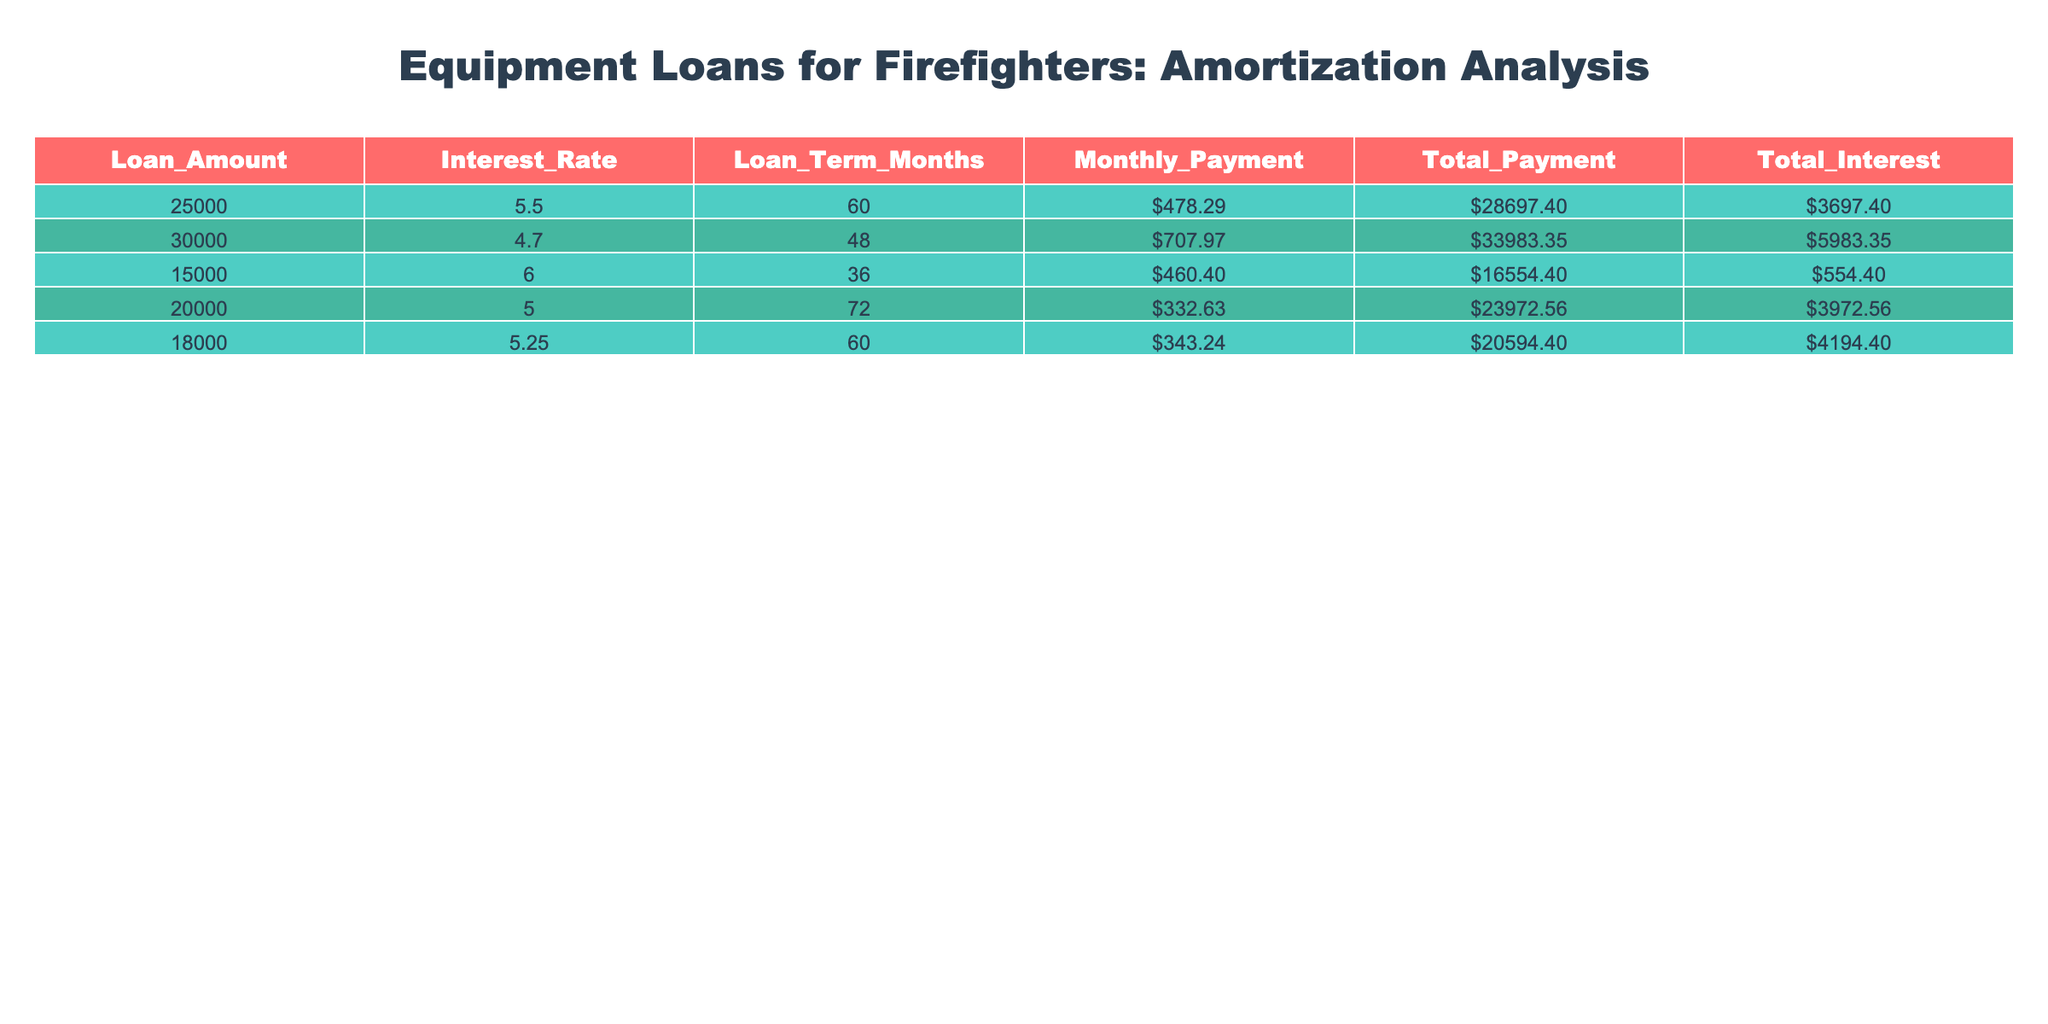What is the loan amount for the equipment with the lowest total interest? From the table, we check the Total Interest column to find the minimum value, which is 554.40. This corresponds to the loan amount of 15000.
Answer: 15000 What is the total payment for the loan with the highest monthly payment? Looking at the Monthly Payment column, the highest value is 707.97. We refer to the same row for the Total Payment, which is 33983.35.
Answer: 33983.35 What is the average total interest across all loans? We sum up all the total interest values: (3697.40 + 5983.35 + 554.40 + 3972.56 + 4194.40) = 18702.11. There are 5 loans, so we divide by 5: 18702.11 / 5 = 3740.42.
Answer: 3740.42 Is the monthly payment for the loan of 20000 larger than the average monthly payment of all loans? The monthly payment for 20000 is 332.63 and the average of all monthly payments is (478.29 + 707.97 + 460.40 + 332.63 + 343.24) / 5 = 464.51, so 332.63 < 464.51. Therefore, it is smaller.
Answer: No What is the difference in total payments between the highest loan amount and the lowest loan amount? The highest loan amount is 30000 with a total payment of 33983.35, and the lowest loan amount is 15000 with a total payment of 16554.40. The difference is 33983.35 - 16554.40 = 17428.95.
Answer: 17428.95 Is the interest rate for the loan of 18000 higher than 5%? The interest rate for 18000 is 5.25%, which is indeed higher than 5%.
Answer: Yes What is the total payment for all loans combined? We sum the Total Payment values: 28697.40 + 33983.35 + 16554.40 + 23972.56 + 20594.40 = 123202.11.
Answer: 123202.11 Which loan term has the longest duration and what is the corresponding total interest? The loan term with the longest duration is 72 months, corresponding to the loan of 20000. The total interest for that loan is 3972.56.
Answer: 3972.56 